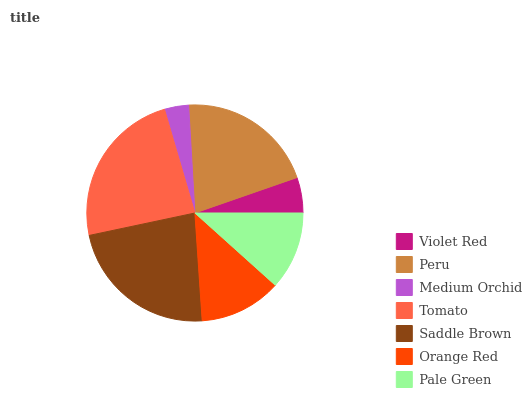Is Medium Orchid the minimum?
Answer yes or no. Yes. Is Tomato the maximum?
Answer yes or no. Yes. Is Peru the minimum?
Answer yes or no. No. Is Peru the maximum?
Answer yes or no. No. Is Peru greater than Violet Red?
Answer yes or no. Yes. Is Violet Red less than Peru?
Answer yes or no. Yes. Is Violet Red greater than Peru?
Answer yes or no. No. Is Peru less than Violet Red?
Answer yes or no. No. Is Orange Red the high median?
Answer yes or no. Yes. Is Orange Red the low median?
Answer yes or no. Yes. Is Medium Orchid the high median?
Answer yes or no. No. Is Violet Red the low median?
Answer yes or no. No. 